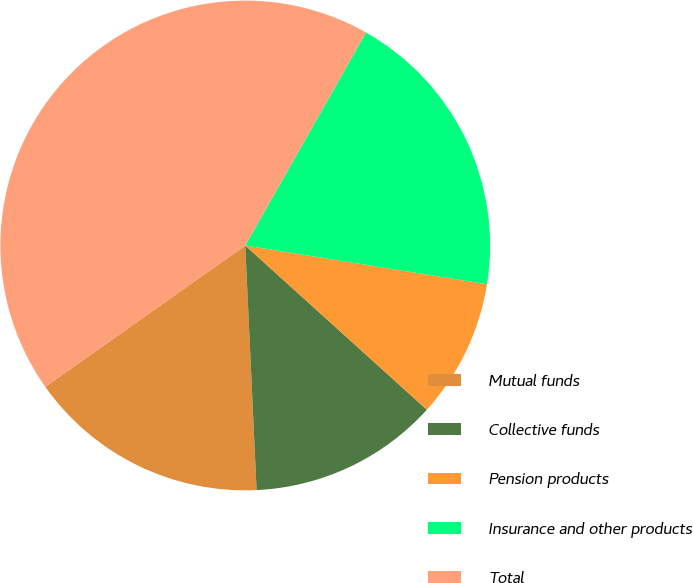<chart> <loc_0><loc_0><loc_500><loc_500><pie_chart><fcel>Mutual funds<fcel>Collective funds<fcel>Pension products<fcel>Insurance and other products<fcel>Total<nl><fcel>15.94%<fcel>12.56%<fcel>9.17%<fcel>19.32%<fcel>43.0%<nl></chart> 